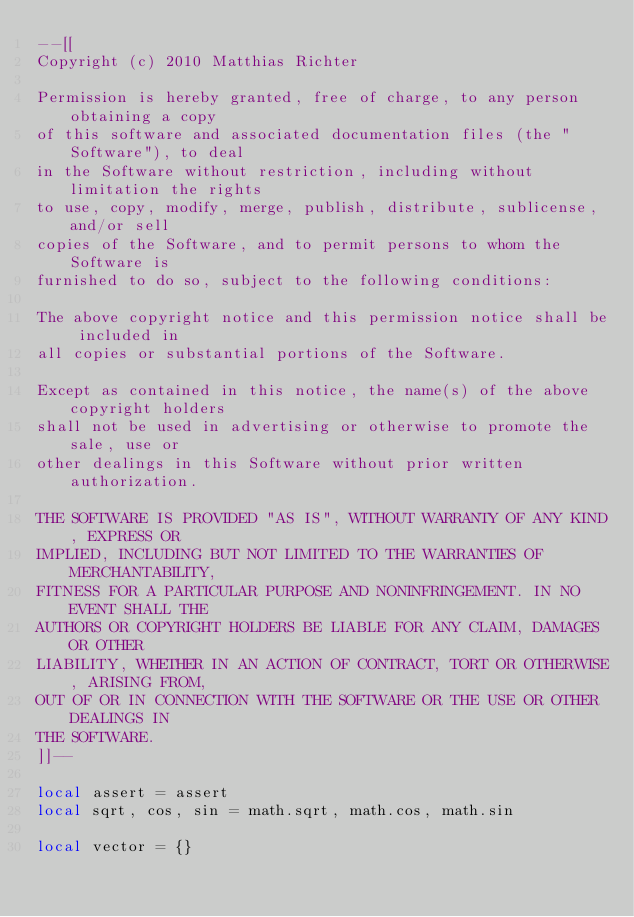Convert code to text. <code><loc_0><loc_0><loc_500><loc_500><_Lua_>--[[
Copyright (c) 2010 Matthias Richter

Permission is hereby granted, free of charge, to any person obtaining a copy
of this software and associated documentation files (the "Software"), to deal
in the Software without restriction, including without limitation the rights
to use, copy, modify, merge, publish, distribute, sublicense, and/or sell
copies of the Software, and to permit persons to whom the Software is
furnished to do so, subject to the following conditions:

The above copyright notice and this permission notice shall be included in
all copies or substantial portions of the Software.

Except as contained in this notice, the name(s) of the above copyright holders
shall not be used in advertising or otherwise to promote the sale, use or
other dealings in this Software without prior written authorization.

THE SOFTWARE IS PROVIDED "AS IS", WITHOUT WARRANTY OF ANY KIND, EXPRESS OR
IMPLIED, INCLUDING BUT NOT LIMITED TO THE WARRANTIES OF MERCHANTABILITY,
FITNESS FOR A PARTICULAR PURPOSE AND NONINFRINGEMENT. IN NO EVENT SHALL THE
AUTHORS OR COPYRIGHT HOLDERS BE LIABLE FOR ANY CLAIM, DAMAGES OR OTHER
LIABILITY, WHETHER IN AN ACTION OF CONTRACT, TORT OR OTHERWISE, ARISING FROM,
OUT OF OR IN CONNECTION WITH THE SOFTWARE OR THE USE OR OTHER DEALINGS IN
THE SOFTWARE.
]]--

local assert = assert
local sqrt, cos, sin = math.sqrt, math.cos, math.sin

local vector = {}</code> 